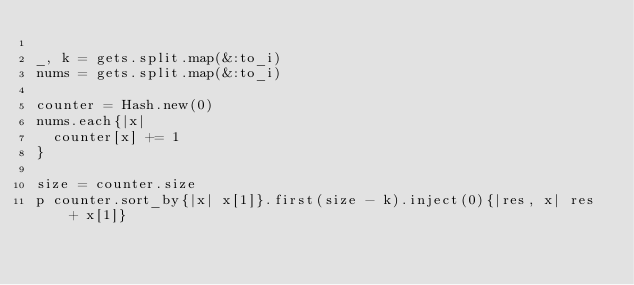<code> <loc_0><loc_0><loc_500><loc_500><_Ruby_>
_, k = gets.split.map(&:to_i)
nums = gets.split.map(&:to_i)

counter = Hash.new(0)
nums.each{|x|
  counter[x] += 1
}

size = counter.size
p counter.sort_by{|x| x[1]}.first(size - k).inject(0){|res, x| res + x[1]}
</code> 